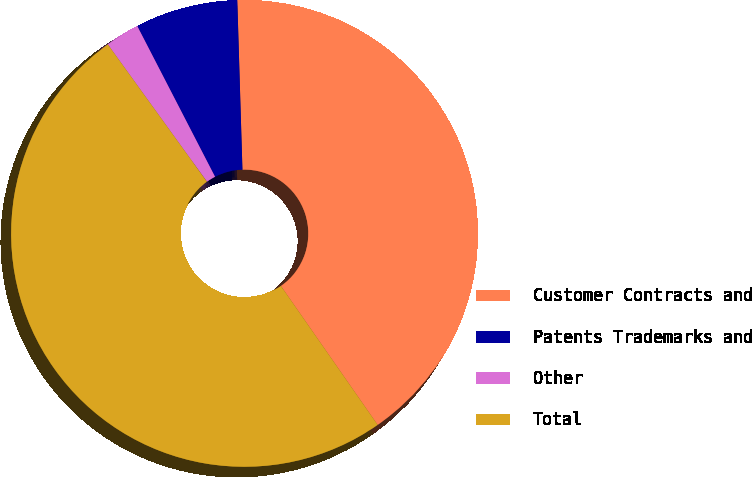Convert chart. <chart><loc_0><loc_0><loc_500><loc_500><pie_chart><fcel>Customer Contracts and<fcel>Patents Trademarks and<fcel>Other<fcel>Total<nl><fcel>40.8%<fcel>7.1%<fcel>2.37%<fcel>49.73%<nl></chart> 